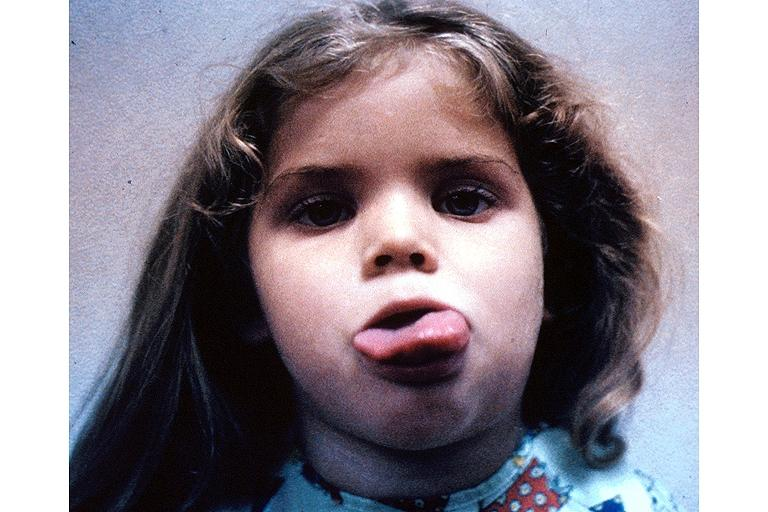where is this?
Answer the question using a single word or phrase. Skin 